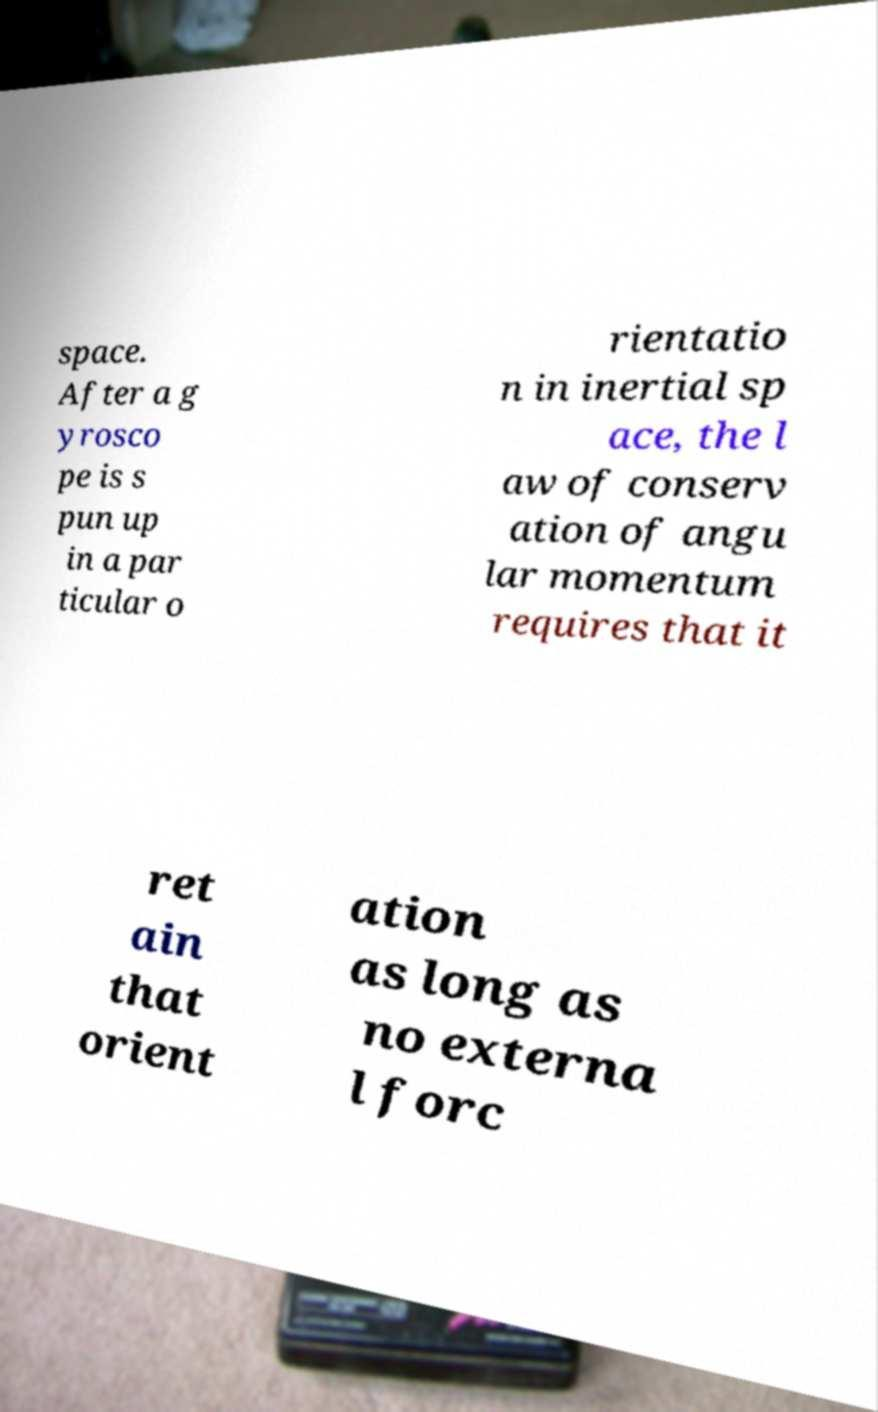Could you assist in decoding the text presented in this image and type it out clearly? space. After a g yrosco pe is s pun up in a par ticular o rientatio n in inertial sp ace, the l aw of conserv ation of angu lar momentum requires that it ret ain that orient ation as long as no externa l forc 